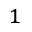<formula> <loc_0><loc_0><loc_500><loc_500>^ { 1 }</formula> 